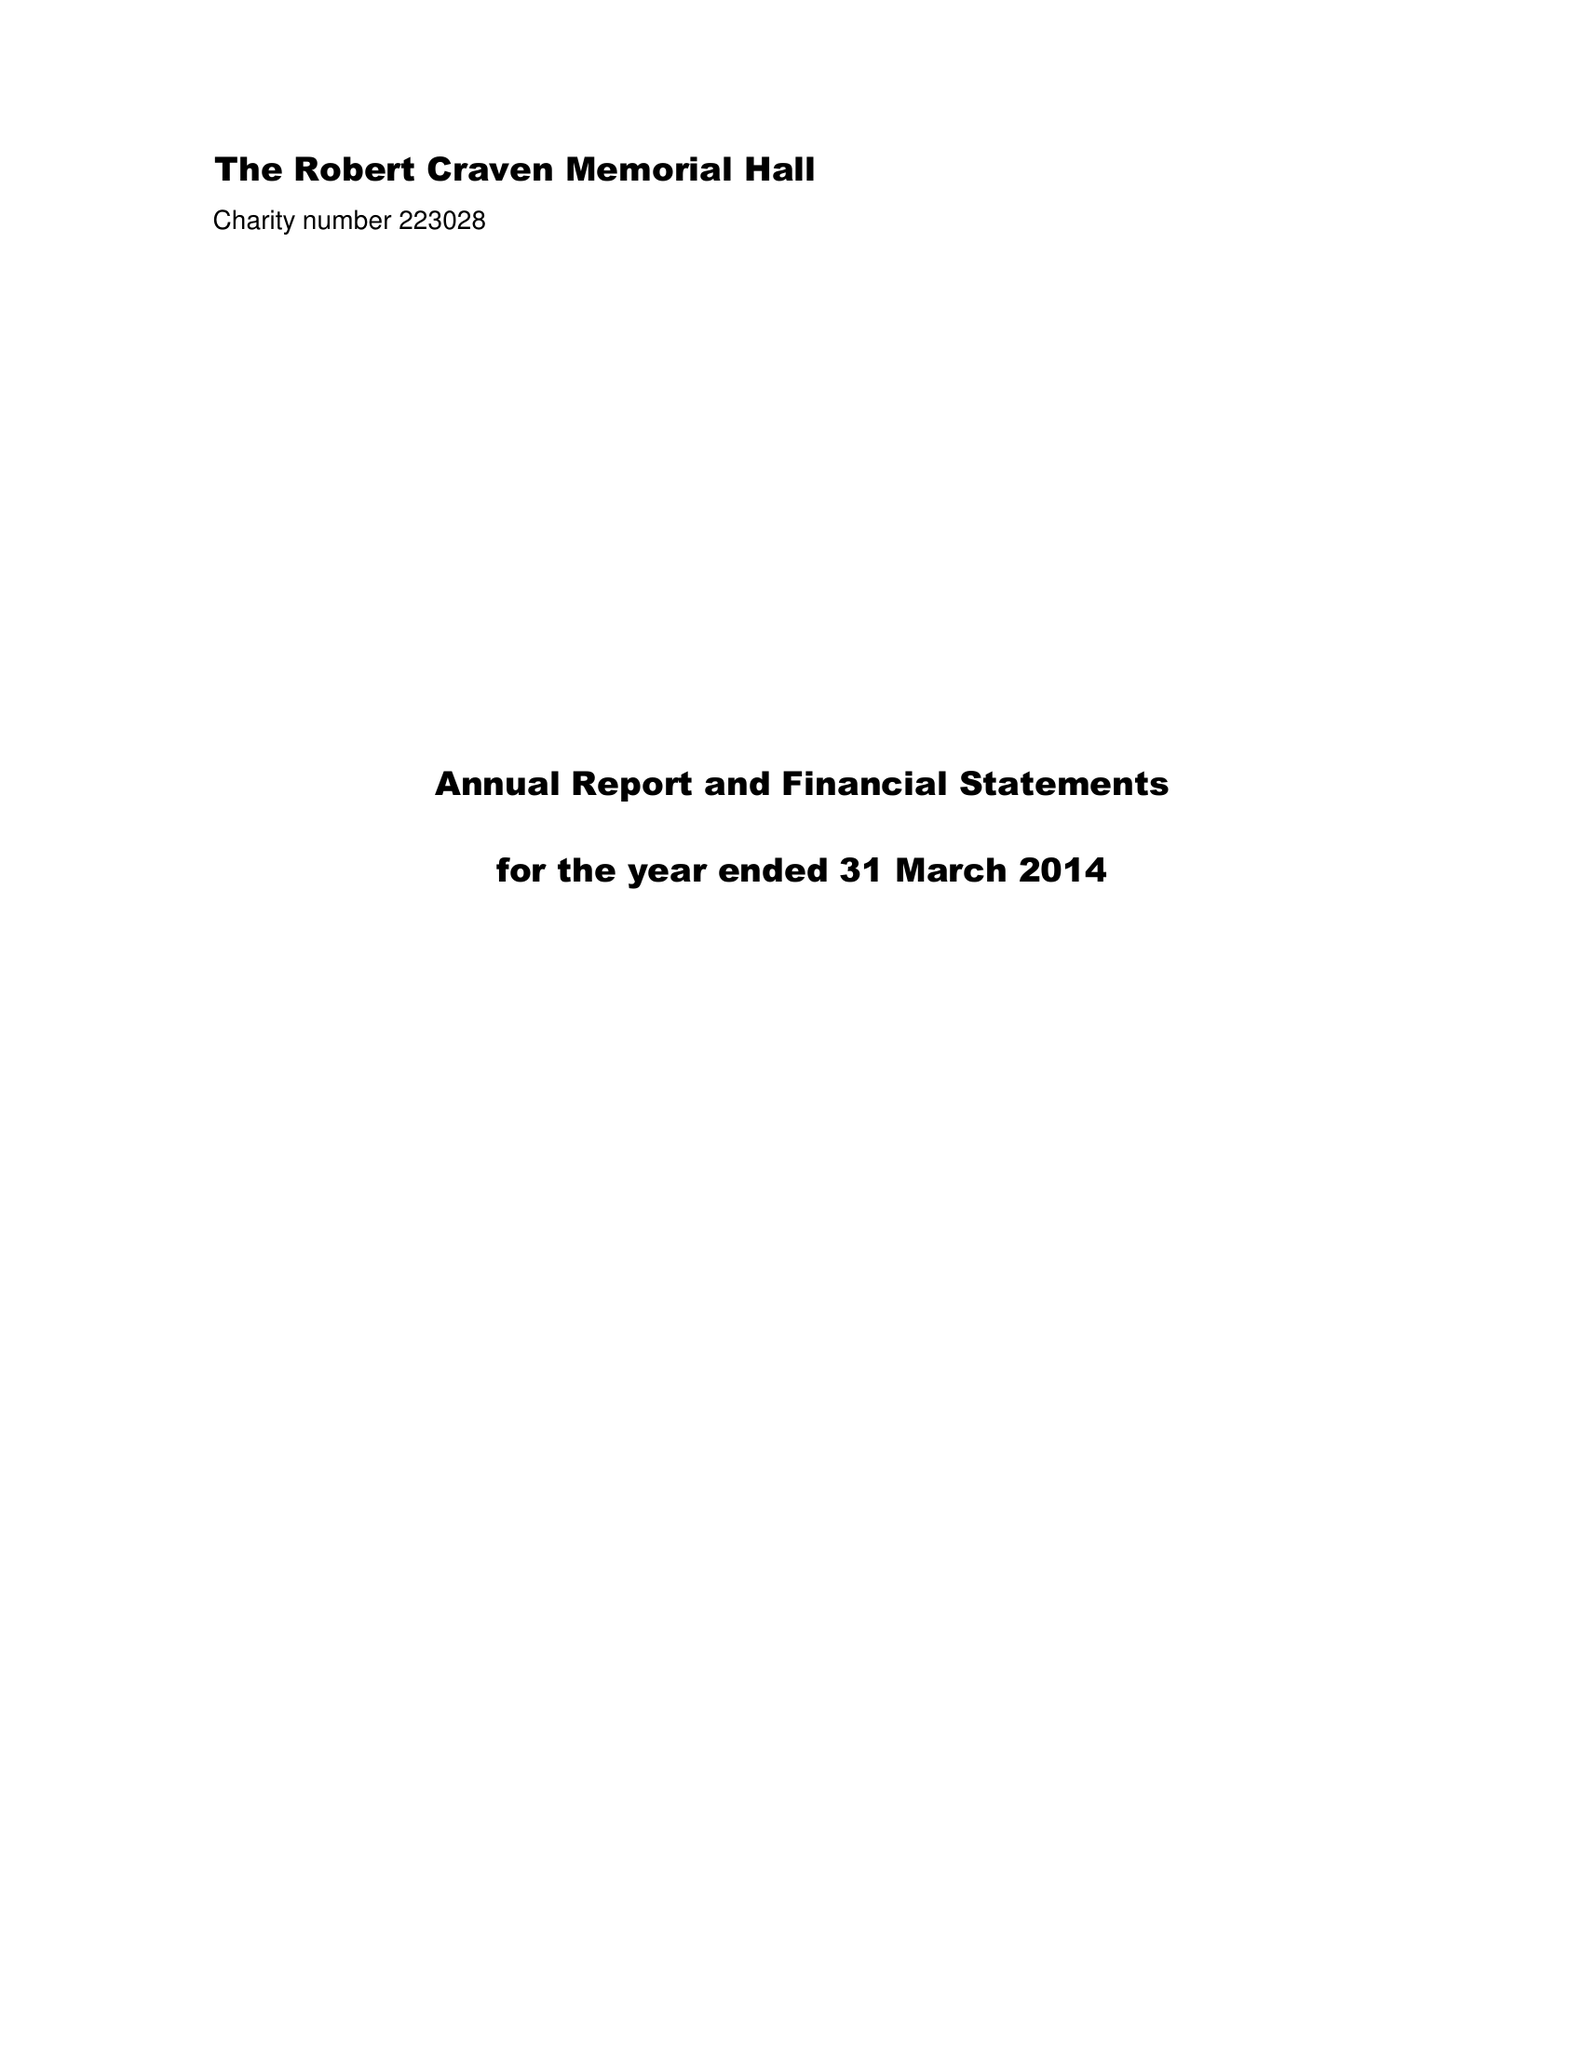What is the value for the address__postcode?
Answer the question using a single word or phrase. LS16 9HJ 